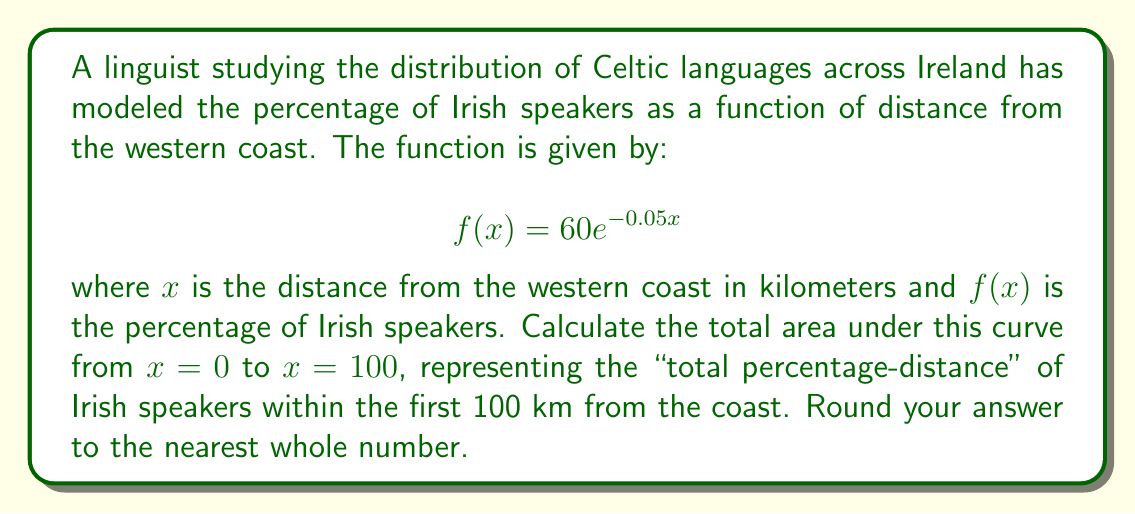Help me with this question. To solve this problem, we need to integrate the given function from 0 to 100. Here's the step-by-step process:

1) The integral we need to evaluate is:

   $$\int_0^{100} 60e^{-0.05x} dx$$

2) To integrate $e^{ax}$, we use the formula: $\int e^{ax} dx = \frac{1}{a}e^{ax} + C$

3) In our case, $a = -0.05$, so:

   $$\int 60e^{-0.05x} dx = 60 \cdot \frac{1}{-0.05}e^{-0.05x} + C = -1200e^{-0.05x} + C$$

4) Now we apply the limits:

   $$[-1200e^{-0.05x}]_0^{100} = -1200e^{-0.05(100)} - (-1200e^{-0.05(0)})$$

5) Simplify:
   
   $$-1200e^{-5} - (-1200) = -1200(e^{-5} - 1)$$

6) Calculate:
   
   $$-1200(0.00674 - 1) = -1200(-0.99326) = 1191.912$$

7) Rounding to the nearest whole number:

   $$1191.912 \approx 1192$$

This result represents the "total percentage-distance" of Irish speakers within the first 100 km from the western coast.
Answer: 1192 